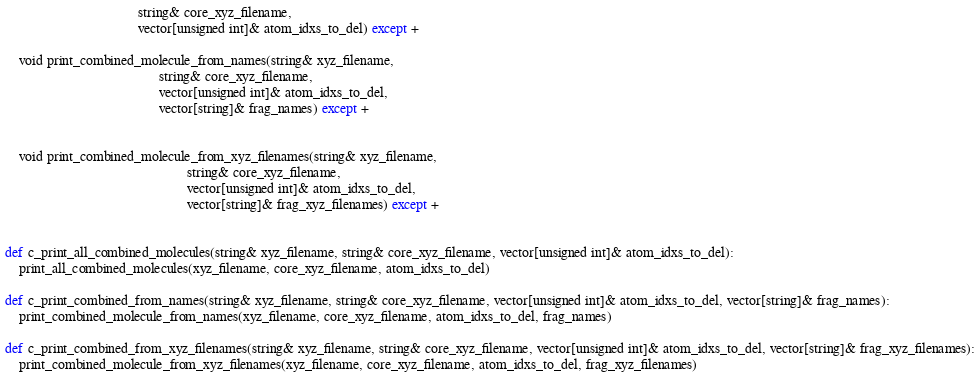Convert code to text. <code><loc_0><loc_0><loc_500><loc_500><_Cython_>                                      string& core_xyz_filename,
                                      vector[unsigned int]& atom_idxs_to_del) except +

    void print_combined_molecule_from_names(string& xyz_filename,
                                            string& core_xyz_filename,
                                            vector[unsigned int]& atom_idxs_to_del,
                                            vector[string]& frag_names) except +


    void print_combined_molecule_from_xyz_filenames(string& xyz_filename,
                                                    string& core_xyz_filename,
                                                    vector[unsigned int]& atom_idxs_to_del,
                                                    vector[string]& frag_xyz_filenames) except +


def c_print_all_combined_molecules(string& xyz_filename, string& core_xyz_filename, vector[unsigned int]& atom_idxs_to_del):
    print_all_combined_molecules(xyz_filename, core_xyz_filename, atom_idxs_to_del)

def c_print_combined_from_names(string& xyz_filename, string& core_xyz_filename, vector[unsigned int]& atom_idxs_to_del, vector[string]& frag_names):
    print_combined_molecule_from_names(xyz_filename, core_xyz_filename, atom_idxs_to_del, frag_names)

def c_print_combined_from_xyz_filenames(string& xyz_filename, string& core_xyz_filename, vector[unsigned int]& atom_idxs_to_del, vector[string]& frag_xyz_filenames):
    print_combined_molecule_from_xyz_filenames(xyz_filename, core_xyz_filename, atom_idxs_to_del, frag_xyz_filenames)
</code> 